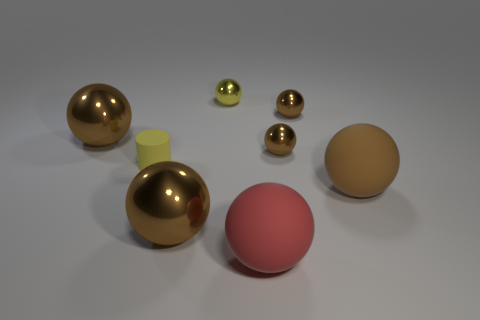How many brown balls must be subtracted to get 3 brown balls? 2 Subtract all big red spheres. How many spheres are left? 6 Add 1 big brown metal spheres. How many objects exist? 9 Subtract all gray blocks. How many brown spheres are left? 5 Subtract 1 cylinders. How many cylinders are left? 0 Subtract all red spheres. How many spheres are left? 6 Subtract all balls. How many objects are left? 1 Add 3 matte balls. How many matte balls are left? 5 Add 4 brown rubber balls. How many brown rubber balls exist? 5 Subtract 0 green balls. How many objects are left? 8 